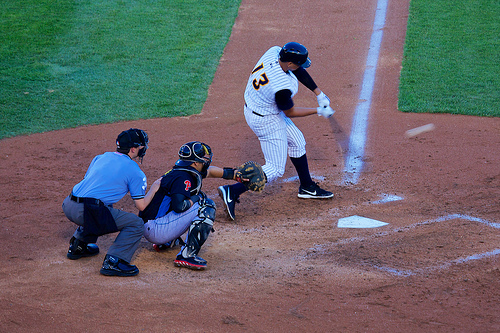Who is wearing the helmet? The batter, engaged in the game, wears the helmet for protection. 